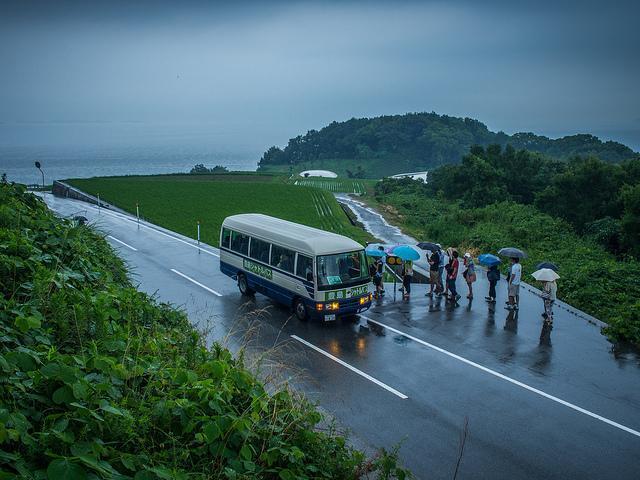How many buses are there?
Give a very brief answer. 1. How many people are there?
Give a very brief answer. 1. How many carrots are there?
Give a very brief answer. 0. 